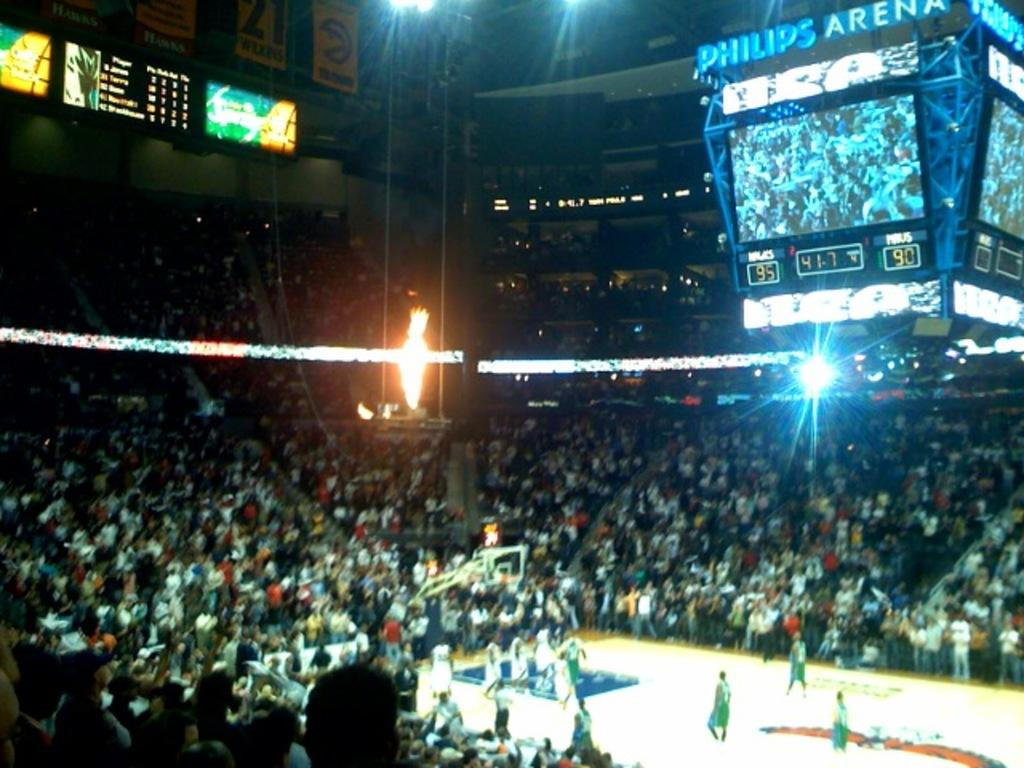<image>
Write a terse but informative summary of the picture. The Philips Arena is hosting a professional basketball game. 